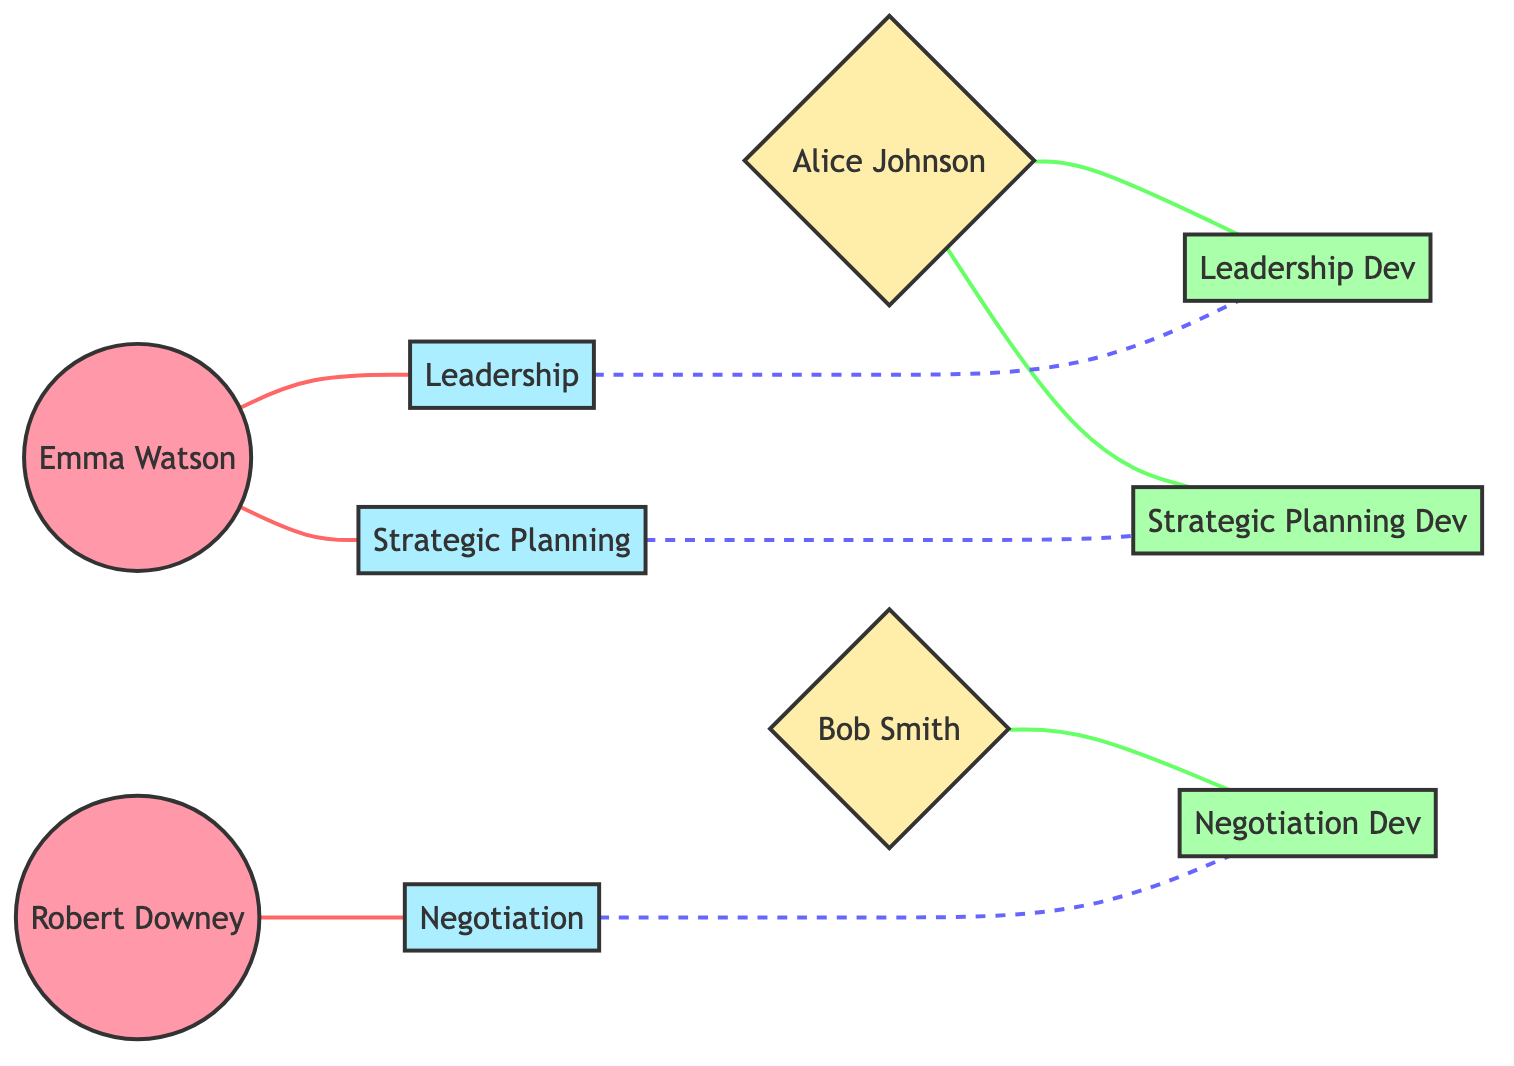What are the names of the senior leaders? The diagram shows two senior leaders: Emma Watson and Robert Downey. These names are located on the nodes identified as "Senior Leader."
Answer: Emma Watson, Robert Downey How many mentees are represented in the diagram? By counting the nodes identified as "Mentee," there are two mentees: Alice Johnson and Bob Smith. Each mentee node distinctly represents a separate individual.
Answer: 2 Which skill is associated with Robert Downey? The diagram shows that Robert Downey is linked to the skill "Negotiation," through the edge labeled as "hasSkill." This linkage indicates that he possesses this particular skill.
Answer: Negotiation Which skills does Alice Johnson need to develop? Alice Johnson is connected to two skills that she needs to develop: "Leadership Dev" and "Strategic Planning Dev." These connections are depicted with edges labeled as "needsDevelopment."
Answer: Leadership, Strategic Planning Which skill is matched with Alice Johnson for her development? The diagram indicates that Alice Johnson's skill development in "Leadership" matches with the mentor skill "Leadership." This is shown by the edge labeled "matchesWith."
Answer: Leadership Which senior leader has skills in both leadership and strategic planning? Emma Watson is the senior leader who has connections to both "Leadership" and "Strategic Planning." This information is derived from the edges showing her skill set.
Answer: Emma Watson How many total skills are represented in the diagram? There are a total of five distinct skills represented in the diagram: "Leadership," "Strategic Planning," "Negotiation," "Leadership Dev," and "Strategic Planning Dev." Thus, the total count is five.
Answer: 5 Which mentee is linked with the negotiation skill development? Bob Smith is the mentee connected to the skill development "Negotiation Dev." This is evident through the edge labeled "needsDevelopment" linking Bob Smith to that skill development node.
Answer: Bob Smith What is the relationship type between Emma Watson and the skill "Strategic Planning"? The relationship type between Emma Watson and "Strategic Planning" is shown by the edge labeled "hasSkill." This indicates that Emma Watson has this skill.
Answer: hasSkill 